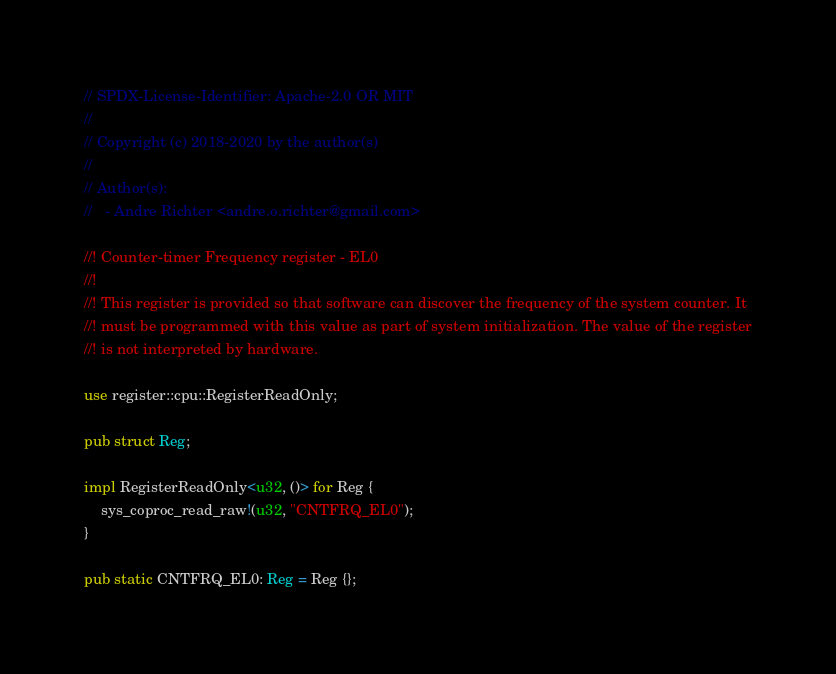<code> <loc_0><loc_0><loc_500><loc_500><_Rust_>// SPDX-License-Identifier: Apache-2.0 OR MIT
//
// Copyright (c) 2018-2020 by the author(s)
//
// Author(s):
//   - Andre Richter <andre.o.richter@gmail.com>

//! Counter-timer Frequency register - EL0
//!
//! This register is provided so that software can discover the frequency of the system counter. It
//! must be programmed with this value as part of system initialization. The value of the register
//! is not interpreted by hardware.

use register::cpu::RegisterReadOnly;

pub struct Reg;

impl RegisterReadOnly<u32, ()> for Reg {
    sys_coproc_read_raw!(u32, "CNTFRQ_EL0");
}

pub static CNTFRQ_EL0: Reg = Reg {};
</code> 